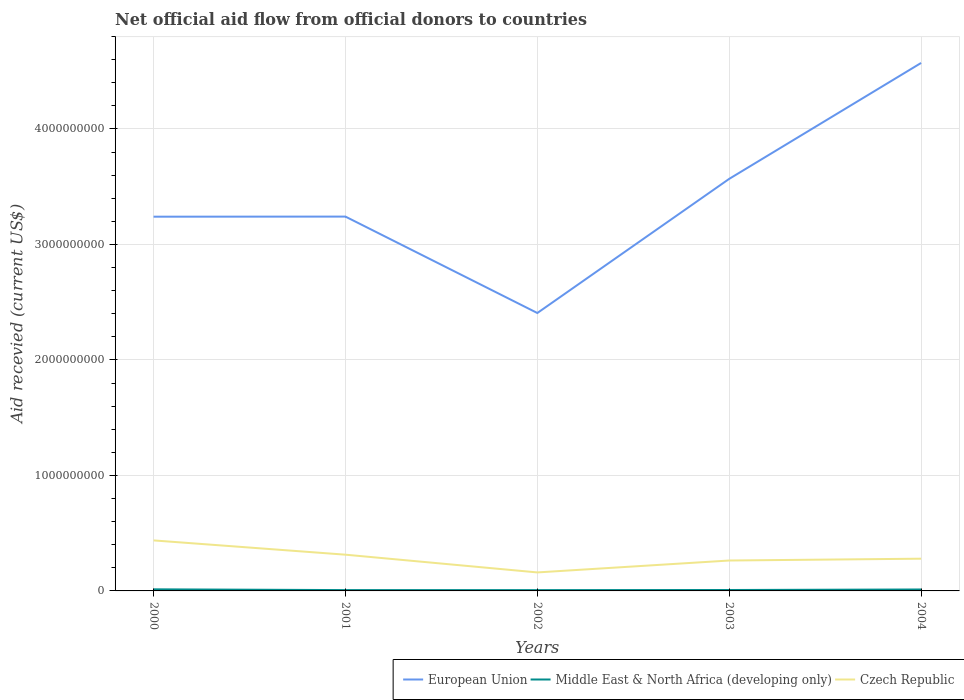Does the line corresponding to Czech Republic intersect with the line corresponding to Middle East & North Africa (developing only)?
Provide a short and direct response. No. Across all years, what is the maximum total aid received in Middle East & North Africa (developing only)?
Make the answer very short. 6.88e+06. What is the total total aid received in European Union in the graph?
Your answer should be compact. 8.34e+08. What is the difference between the highest and the second highest total aid received in Czech Republic?
Your answer should be very brief. 2.77e+08. How many years are there in the graph?
Ensure brevity in your answer.  5. Are the values on the major ticks of Y-axis written in scientific E-notation?
Ensure brevity in your answer.  No. Where does the legend appear in the graph?
Offer a very short reply. Bottom right. What is the title of the graph?
Provide a short and direct response. Net official aid flow from official donors to countries. Does "United Kingdom" appear as one of the legend labels in the graph?
Provide a short and direct response. No. What is the label or title of the Y-axis?
Provide a short and direct response. Aid recevied (current US$). What is the Aid recevied (current US$) in European Union in 2000?
Offer a very short reply. 3.24e+09. What is the Aid recevied (current US$) in Middle East & North Africa (developing only) in 2000?
Your response must be concise. 1.38e+07. What is the Aid recevied (current US$) of Czech Republic in 2000?
Give a very brief answer. 4.37e+08. What is the Aid recevied (current US$) of European Union in 2001?
Give a very brief answer. 3.24e+09. What is the Aid recevied (current US$) in Middle East & North Africa (developing only) in 2001?
Your response must be concise. 7.14e+06. What is the Aid recevied (current US$) in Czech Republic in 2001?
Ensure brevity in your answer.  3.14e+08. What is the Aid recevied (current US$) of European Union in 2002?
Your answer should be very brief. 2.41e+09. What is the Aid recevied (current US$) of Middle East & North Africa (developing only) in 2002?
Provide a succinct answer. 6.88e+06. What is the Aid recevied (current US$) of Czech Republic in 2002?
Ensure brevity in your answer.  1.60e+08. What is the Aid recevied (current US$) in European Union in 2003?
Offer a very short reply. 3.57e+09. What is the Aid recevied (current US$) in Middle East & North Africa (developing only) in 2003?
Make the answer very short. 7.95e+06. What is the Aid recevied (current US$) in Czech Republic in 2003?
Your answer should be compact. 2.63e+08. What is the Aid recevied (current US$) of European Union in 2004?
Your response must be concise. 4.57e+09. What is the Aid recevied (current US$) of Middle East & North Africa (developing only) in 2004?
Give a very brief answer. 1.24e+07. What is the Aid recevied (current US$) of Czech Republic in 2004?
Offer a very short reply. 2.79e+08. Across all years, what is the maximum Aid recevied (current US$) of European Union?
Ensure brevity in your answer.  4.57e+09. Across all years, what is the maximum Aid recevied (current US$) in Middle East & North Africa (developing only)?
Your response must be concise. 1.38e+07. Across all years, what is the maximum Aid recevied (current US$) in Czech Republic?
Make the answer very short. 4.37e+08. Across all years, what is the minimum Aid recevied (current US$) in European Union?
Ensure brevity in your answer.  2.41e+09. Across all years, what is the minimum Aid recevied (current US$) in Middle East & North Africa (developing only)?
Give a very brief answer. 6.88e+06. Across all years, what is the minimum Aid recevied (current US$) in Czech Republic?
Offer a terse response. 1.60e+08. What is the total Aid recevied (current US$) of European Union in the graph?
Give a very brief answer. 1.70e+1. What is the total Aid recevied (current US$) of Middle East & North Africa (developing only) in the graph?
Your answer should be very brief. 4.82e+07. What is the total Aid recevied (current US$) in Czech Republic in the graph?
Keep it short and to the point. 1.45e+09. What is the difference between the Aid recevied (current US$) in European Union in 2000 and that in 2001?
Your answer should be very brief. -7.70e+05. What is the difference between the Aid recevied (current US$) in Middle East & North Africa (developing only) in 2000 and that in 2001?
Offer a terse response. 6.61e+06. What is the difference between the Aid recevied (current US$) of Czech Republic in 2000 and that in 2001?
Provide a succinct answer. 1.24e+08. What is the difference between the Aid recevied (current US$) in European Union in 2000 and that in 2002?
Your answer should be very brief. 8.34e+08. What is the difference between the Aid recevied (current US$) of Middle East & North Africa (developing only) in 2000 and that in 2002?
Your answer should be very brief. 6.87e+06. What is the difference between the Aid recevied (current US$) of Czech Republic in 2000 and that in 2002?
Ensure brevity in your answer.  2.77e+08. What is the difference between the Aid recevied (current US$) in European Union in 2000 and that in 2003?
Your response must be concise. -3.28e+08. What is the difference between the Aid recevied (current US$) in Middle East & North Africa (developing only) in 2000 and that in 2003?
Your answer should be very brief. 5.80e+06. What is the difference between the Aid recevied (current US$) of Czech Republic in 2000 and that in 2003?
Keep it short and to the point. 1.74e+08. What is the difference between the Aid recevied (current US$) of European Union in 2000 and that in 2004?
Make the answer very short. -1.33e+09. What is the difference between the Aid recevied (current US$) in Middle East & North Africa (developing only) in 2000 and that in 2004?
Ensure brevity in your answer.  1.32e+06. What is the difference between the Aid recevied (current US$) in Czech Republic in 2000 and that in 2004?
Provide a succinct answer. 1.58e+08. What is the difference between the Aid recevied (current US$) in European Union in 2001 and that in 2002?
Provide a succinct answer. 8.35e+08. What is the difference between the Aid recevied (current US$) in Middle East & North Africa (developing only) in 2001 and that in 2002?
Keep it short and to the point. 2.60e+05. What is the difference between the Aid recevied (current US$) in Czech Republic in 2001 and that in 2002?
Offer a terse response. 1.54e+08. What is the difference between the Aid recevied (current US$) of European Union in 2001 and that in 2003?
Provide a succinct answer. -3.27e+08. What is the difference between the Aid recevied (current US$) in Middle East & North Africa (developing only) in 2001 and that in 2003?
Provide a short and direct response. -8.10e+05. What is the difference between the Aid recevied (current US$) in Czech Republic in 2001 and that in 2003?
Your answer should be very brief. 5.05e+07. What is the difference between the Aid recevied (current US$) of European Union in 2001 and that in 2004?
Your response must be concise. -1.33e+09. What is the difference between the Aid recevied (current US$) of Middle East & North Africa (developing only) in 2001 and that in 2004?
Give a very brief answer. -5.29e+06. What is the difference between the Aid recevied (current US$) of Czech Republic in 2001 and that in 2004?
Your response must be concise. 3.47e+07. What is the difference between the Aid recevied (current US$) of European Union in 2002 and that in 2003?
Give a very brief answer. -1.16e+09. What is the difference between the Aid recevied (current US$) of Middle East & North Africa (developing only) in 2002 and that in 2003?
Ensure brevity in your answer.  -1.07e+06. What is the difference between the Aid recevied (current US$) of Czech Republic in 2002 and that in 2003?
Give a very brief answer. -1.03e+08. What is the difference between the Aid recevied (current US$) in European Union in 2002 and that in 2004?
Your answer should be compact. -2.17e+09. What is the difference between the Aid recevied (current US$) of Middle East & North Africa (developing only) in 2002 and that in 2004?
Your response must be concise. -5.55e+06. What is the difference between the Aid recevied (current US$) of Czech Republic in 2002 and that in 2004?
Provide a succinct answer. -1.19e+08. What is the difference between the Aid recevied (current US$) in European Union in 2003 and that in 2004?
Your response must be concise. -1.00e+09. What is the difference between the Aid recevied (current US$) of Middle East & North Africa (developing only) in 2003 and that in 2004?
Your answer should be compact. -4.48e+06. What is the difference between the Aid recevied (current US$) in Czech Republic in 2003 and that in 2004?
Your answer should be compact. -1.58e+07. What is the difference between the Aid recevied (current US$) in European Union in 2000 and the Aid recevied (current US$) in Middle East & North Africa (developing only) in 2001?
Give a very brief answer. 3.23e+09. What is the difference between the Aid recevied (current US$) in European Union in 2000 and the Aid recevied (current US$) in Czech Republic in 2001?
Your answer should be compact. 2.93e+09. What is the difference between the Aid recevied (current US$) in Middle East & North Africa (developing only) in 2000 and the Aid recevied (current US$) in Czech Republic in 2001?
Give a very brief answer. -3.00e+08. What is the difference between the Aid recevied (current US$) in European Union in 2000 and the Aid recevied (current US$) in Middle East & North Africa (developing only) in 2002?
Your answer should be very brief. 3.23e+09. What is the difference between the Aid recevied (current US$) in European Union in 2000 and the Aid recevied (current US$) in Czech Republic in 2002?
Make the answer very short. 3.08e+09. What is the difference between the Aid recevied (current US$) of Middle East & North Africa (developing only) in 2000 and the Aid recevied (current US$) of Czech Republic in 2002?
Make the answer very short. -1.46e+08. What is the difference between the Aid recevied (current US$) in European Union in 2000 and the Aid recevied (current US$) in Middle East & North Africa (developing only) in 2003?
Offer a terse response. 3.23e+09. What is the difference between the Aid recevied (current US$) in European Union in 2000 and the Aid recevied (current US$) in Czech Republic in 2003?
Give a very brief answer. 2.98e+09. What is the difference between the Aid recevied (current US$) in Middle East & North Africa (developing only) in 2000 and the Aid recevied (current US$) in Czech Republic in 2003?
Provide a succinct answer. -2.50e+08. What is the difference between the Aid recevied (current US$) in European Union in 2000 and the Aid recevied (current US$) in Middle East & North Africa (developing only) in 2004?
Provide a short and direct response. 3.23e+09. What is the difference between the Aid recevied (current US$) of European Union in 2000 and the Aid recevied (current US$) of Czech Republic in 2004?
Make the answer very short. 2.96e+09. What is the difference between the Aid recevied (current US$) in Middle East & North Africa (developing only) in 2000 and the Aid recevied (current US$) in Czech Republic in 2004?
Ensure brevity in your answer.  -2.65e+08. What is the difference between the Aid recevied (current US$) of European Union in 2001 and the Aid recevied (current US$) of Middle East & North Africa (developing only) in 2002?
Provide a succinct answer. 3.23e+09. What is the difference between the Aid recevied (current US$) in European Union in 2001 and the Aid recevied (current US$) in Czech Republic in 2002?
Offer a terse response. 3.08e+09. What is the difference between the Aid recevied (current US$) in Middle East & North Africa (developing only) in 2001 and the Aid recevied (current US$) in Czech Republic in 2002?
Your response must be concise. -1.53e+08. What is the difference between the Aid recevied (current US$) of European Union in 2001 and the Aid recevied (current US$) of Middle East & North Africa (developing only) in 2003?
Ensure brevity in your answer.  3.23e+09. What is the difference between the Aid recevied (current US$) in European Union in 2001 and the Aid recevied (current US$) in Czech Republic in 2003?
Make the answer very short. 2.98e+09. What is the difference between the Aid recevied (current US$) in Middle East & North Africa (developing only) in 2001 and the Aid recevied (current US$) in Czech Republic in 2003?
Provide a short and direct response. -2.56e+08. What is the difference between the Aid recevied (current US$) of European Union in 2001 and the Aid recevied (current US$) of Middle East & North Africa (developing only) in 2004?
Keep it short and to the point. 3.23e+09. What is the difference between the Aid recevied (current US$) in European Union in 2001 and the Aid recevied (current US$) in Czech Republic in 2004?
Ensure brevity in your answer.  2.96e+09. What is the difference between the Aid recevied (current US$) in Middle East & North Africa (developing only) in 2001 and the Aid recevied (current US$) in Czech Republic in 2004?
Offer a very short reply. -2.72e+08. What is the difference between the Aid recevied (current US$) of European Union in 2002 and the Aid recevied (current US$) of Middle East & North Africa (developing only) in 2003?
Make the answer very short. 2.40e+09. What is the difference between the Aid recevied (current US$) in European Union in 2002 and the Aid recevied (current US$) in Czech Republic in 2003?
Your response must be concise. 2.14e+09. What is the difference between the Aid recevied (current US$) in Middle East & North Africa (developing only) in 2002 and the Aid recevied (current US$) in Czech Republic in 2003?
Provide a short and direct response. -2.56e+08. What is the difference between the Aid recevied (current US$) of European Union in 2002 and the Aid recevied (current US$) of Middle East & North Africa (developing only) in 2004?
Make the answer very short. 2.39e+09. What is the difference between the Aid recevied (current US$) in European Union in 2002 and the Aid recevied (current US$) in Czech Republic in 2004?
Make the answer very short. 2.13e+09. What is the difference between the Aid recevied (current US$) of Middle East & North Africa (developing only) in 2002 and the Aid recevied (current US$) of Czech Republic in 2004?
Provide a succinct answer. -2.72e+08. What is the difference between the Aid recevied (current US$) in European Union in 2003 and the Aid recevied (current US$) in Middle East & North Africa (developing only) in 2004?
Offer a terse response. 3.56e+09. What is the difference between the Aid recevied (current US$) in European Union in 2003 and the Aid recevied (current US$) in Czech Republic in 2004?
Offer a very short reply. 3.29e+09. What is the difference between the Aid recevied (current US$) in Middle East & North Africa (developing only) in 2003 and the Aid recevied (current US$) in Czech Republic in 2004?
Your answer should be very brief. -2.71e+08. What is the average Aid recevied (current US$) of European Union per year?
Your response must be concise. 3.41e+09. What is the average Aid recevied (current US$) of Middle East & North Africa (developing only) per year?
Provide a succinct answer. 9.63e+06. What is the average Aid recevied (current US$) in Czech Republic per year?
Keep it short and to the point. 2.91e+08. In the year 2000, what is the difference between the Aid recevied (current US$) of European Union and Aid recevied (current US$) of Middle East & North Africa (developing only)?
Offer a terse response. 3.23e+09. In the year 2000, what is the difference between the Aid recevied (current US$) in European Union and Aid recevied (current US$) in Czech Republic?
Make the answer very short. 2.80e+09. In the year 2000, what is the difference between the Aid recevied (current US$) of Middle East & North Africa (developing only) and Aid recevied (current US$) of Czech Republic?
Your answer should be very brief. -4.24e+08. In the year 2001, what is the difference between the Aid recevied (current US$) in European Union and Aid recevied (current US$) in Middle East & North Africa (developing only)?
Your answer should be compact. 3.23e+09. In the year 2001, what is the difference between the Aid recevied (current US$) of European Union and Aid recevied (current US$) of Czech Republic?
Provide a succinct answer. 2.93e+09. In the year 2001, what is the difference between the Aid recevied (current US$) of Middle East & North Africa (developing only) and Aid recevied (current US$) of Czech Republic?
Provide a succinct answer. -3.07e+08. In the year 2002, what is the difference between the Aid recevied (current US$) of European Union and Aid recevied (current US$) of Middle East & North Africa (developing only)?
Your answer should be very brief. 2.40e+09. In the year 2002, what is the difference between the Aid recevied (current US$) in European Union and Aid recevied (current US$) in Czech Republic?
Ensure brevity in your answer.  2.25e+09. In the year 2002, what is the difference between the Aid recevied (current US$) of Middle East & North Africa (developing only) and Aid recevied (current US$) of Czech Republic?
Offer a very short reply. -1.53e+08. In the year 2003, what is the difference between the Aid recevied (current US$) in European Union and Aid recevied (current US$) in Middle East & North Africa (developing only)?
Give a very brief answer. 3.56e+09. In the year 2003, what is the difference between the Aid recevied (current US$) of European Union and Aid recevied (current US$) of Czech Republic?
Provide a short and direct response. 3.30e+09. In the year 2003, what is the difference between the Aid recevied (current US$) in Middle East & North Africa (developing only) and Aid recevied (current US$) in Czech Republic?
Your answer should be compact. -2.55e+08. In the year 2004, what is the difference between the Aid recevied (current US$) in European Union and Aid recevied (current US$) in Middle East & North Africa (developing only)?
Your response must be concise. 4.56e+09. In the year 2004, what is the difference between the Aid recevied (current US$) of European Union and Aid recevied (current US$) of Czech Republic?
Give a very brief answer. 4.29e+09. In the year 2004, what is the difference between the Aid recevied (current US$) of Middle East & North Africa (developing only) and Aid recevied (current US$) of Czech Republic?
Your answer should be compact. -2.67e+08. What is the ratio of the Aid recevied (current US$) in European Union in 2000 to that in 2001?
Your answer should be compact. 1. What is the ratio of the Aid recevied (current US$) in Middle East & North Africa (developing only) in 2000 to that in 2001?
Offer a terse response. 1.93. What is the ratio of the Aid recevied (current US$) in Czech Republic in 2000 to that in 2001?
Your answer should be very brief. 1.39. What is the ratio of the Aid recevied (current US$) of European Union in 2000 to that in 2002?
Provide a short and direct response. 1.35. What is the ratio of the Aid recevied (current US$) of Middle East & North Africa (developing only) in 2000 to that in 2002?
Ensure brevity in your answer.  2. What is the ratio of the Aid recevied (current US$) in Czech Republic in 2000 to that in 2002?
Provide a short and direct response. 2.73. What is the ratio of the Aid recevied (current US$) in European Union in 2000 to that in 2003?
Ensure brevity in your answer.  0.91. What is the ratio of the Aid recevied (current US$) in Middle East & North Africa (developing only) in 2000 to that in 2003?
Your answer should be compact. 1.73. What is the ratio of the Aid recevied (current US$) in Czech Republic in 2000 to that in 2003?
Your response must be concise. 1.66. What is the ratio of the Aid recevied (current US$) of European Union in 2000 to that in 2004?
Ensure brevity in your answer.  0.71. What is the ratio of the Aid recevied (current US$) in Middle East & North Africa (developing only) in 2000 to that in 2004?
Make the answer very short. 1.11. What is the ratio of the Aid recevied (current US$) of Czech Republic in 2000 to that in 2004?
Your answer should be compact. 1.57. What is the ratio of the Aid recevied (current US$) of European Union in 2001 to that in 2002?
Provide a succinct answer. 1.35. What is the ratio of the Aid recevied (current US$) in Middle East & North Africa (developing only) in 2001 to that in 2002?
Offer a very short reply. 1.04. What is the ratio of the Aid recevied (current US$) of Czech Republic in 2001 to that in 2002?
Provide a succinct answer. 1.96. What is the ratio of the Aid recevied (current US$) of European Union in 2001 to that in 2003?
Keep it short and to the point. 0.91. What is the ratio of the Aid recevied (current US$) of Middle East & North Africa (developing only) in 2001 to that in 2003?
Your answer should be very brief. 0.9. What is the ratio of the Aid recevied (current US$) of Czech Republic in 2001 to that in 2003?
Offer a terse response. 1.19. What is the ratio of the Aid recevied (current US$) in European Union in 2001 to that in 2004?
Make the answer very short. 0.71. What is the ratio of the Aid recevied (current US$) of Middle East & North Africa (developing only) in 2001 to that in 2004?
Your answer should be compact. 0.57. What is the ratio of the Aid recevied (current US$) of Czech Republic in 2001 to that in 2004?
Your answer should be very brief. 1.12. What is the ratio of the Aid recevied (current US$) of European Union in 2002 to that in 2003?
Your answer should be very brief. 0.67. What is the ratio of the Aid recevied (current US$) of Middle East & North Africa (developing only) in 2002 to that in 2003?
Offer a terse response. 0.87. What is the ratio of the Aid recevied (current US$) in Czech Republic in 2002 to that in 2003?
Your answer should be very brief. 0.61. What is the ratio of the Aid recevied (current US$) in European Union in 2002 to that in 2004?
Your answer should be very brief. 0.53. What is the ratio of the Aid recevied (current US$) in Middle East & North Africa (developing only) in 2002 to that in 2004?
Provide a succinct answer. 0.55. What is the ratio of the Aid recevied (current US$) in Czech Republic in 2002 to that in 2004?
Make the answer very short. 0.57. What is the ratio of the Aid recevied (current US$) of European Union in 2003 to that in 2004?
Your answer should be compact. 0.78. What is the ratio of the Aid recevied (current US$) in Middle East & North Africa (developing only) in 2003 to that in 2004?
Make the answer very short. 0.64. What is the ratio of the Aid recevied (current US$) of Czech Republic in 2003 to that in 2004?
Your answer should be very brief. 0.94. What is the difference between the highest and the second highest Aid recevied (current US$) of European Union?
Give a very brief answer. 1.00e+09. What is the difference between the highest and the second highest Aid recevied (current US$) in Middle East & North Africa (developing only)?
Keep it short and to the point. 1.32e+06. What is the difference between the highest and the second highest Aid recevied (current US$) of Czech Republic?
Give a very brief answer. 1.24e+08. What is the difference between the highest and the lowest Aid recevied (current US$) in European Union?
Provide a succinct answer. 2.17e+09. What is the difference between the highest and the lowest Aid recevied (current US$) of Middle East & North Africa (developing only)?
Provide a short and direct response. 6.87e+06. What is the difference between the highest and the lowest Aid recevied (current US$) of Czech Republic?
Your answer should be compact. 2.77e+08. 